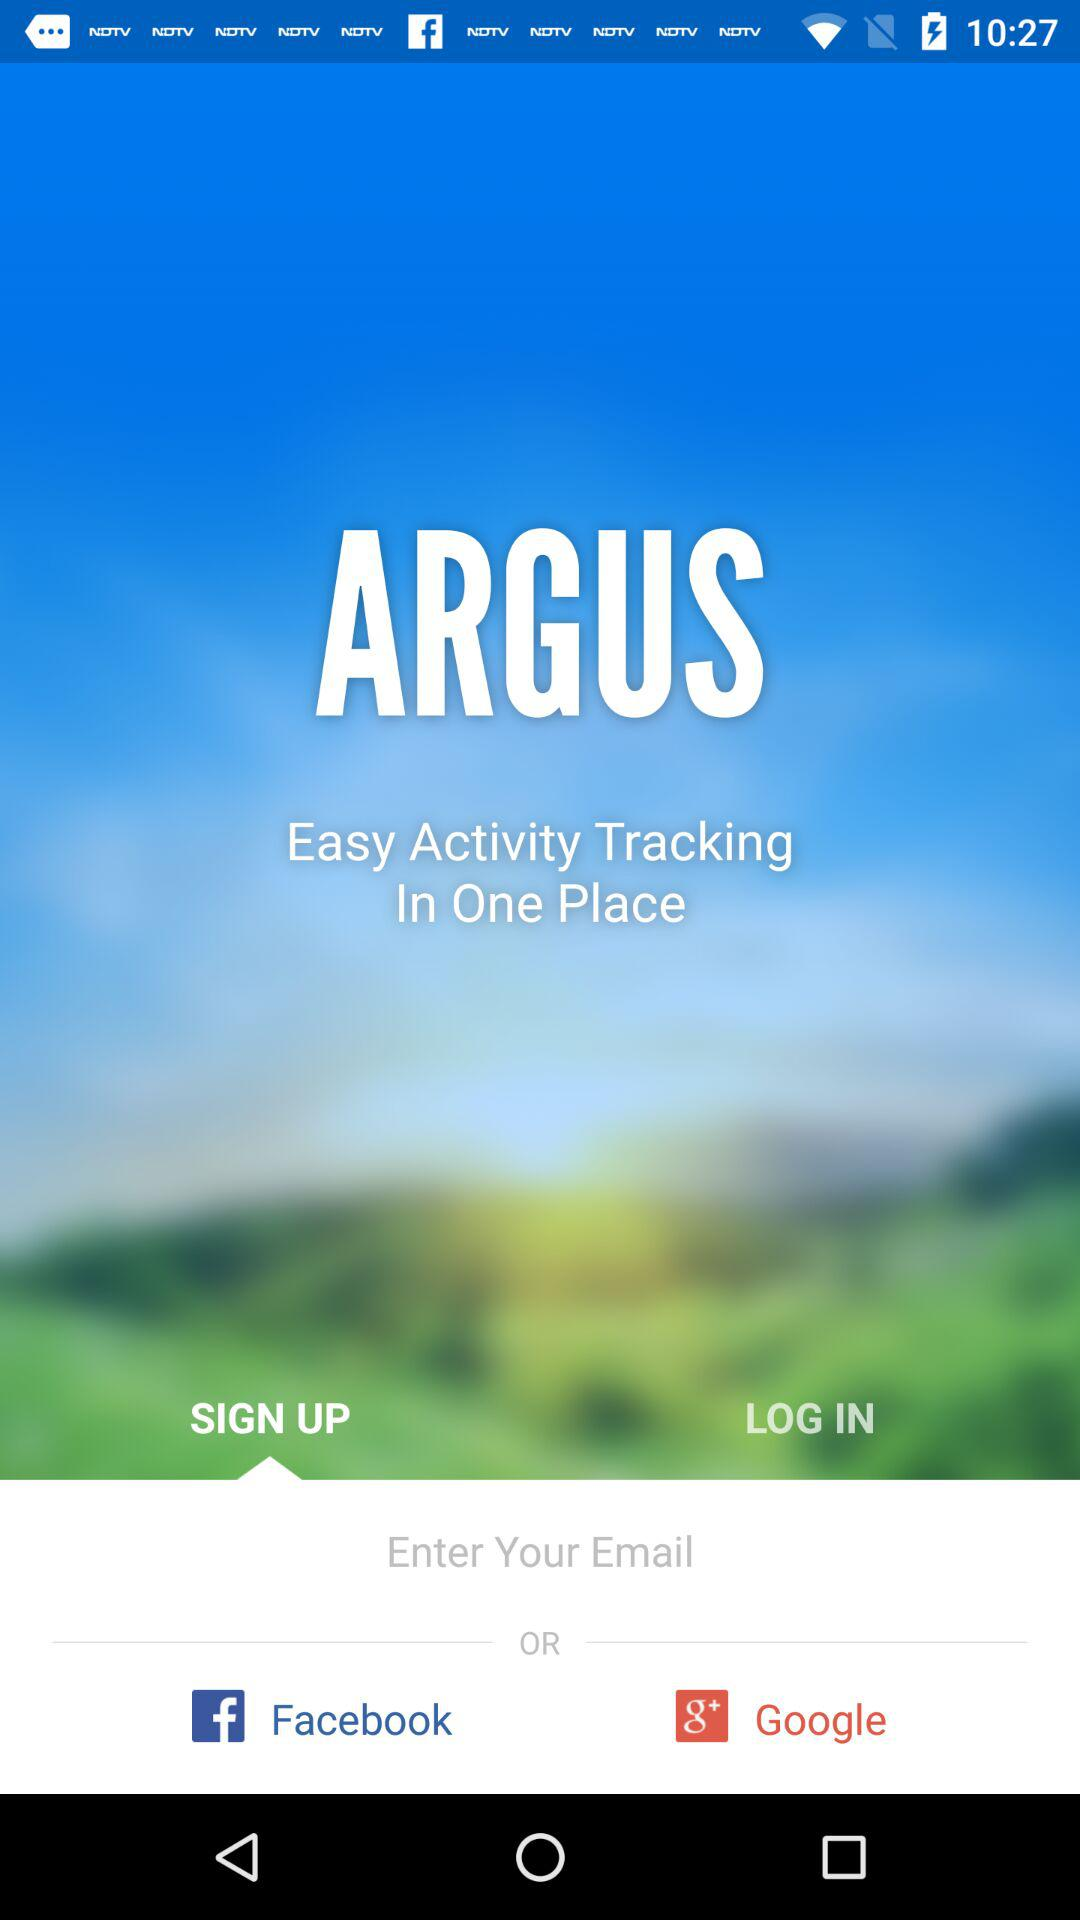What is the name of the application? The name of the application is "ARGUS". 